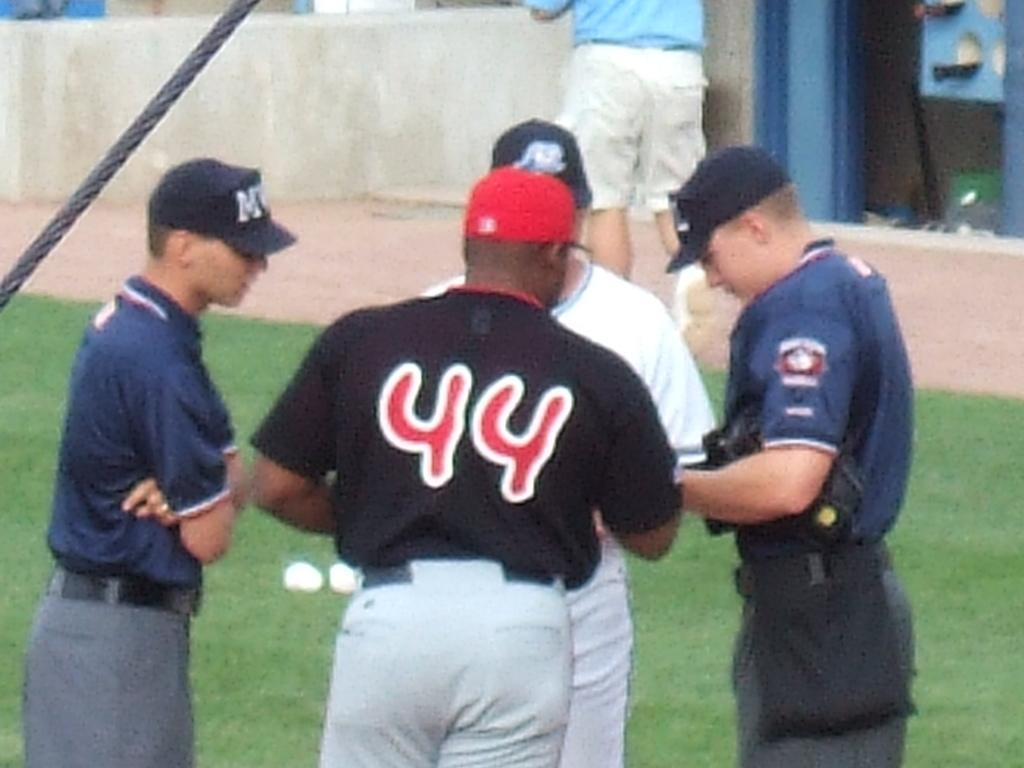Provide a one-sentence caption for the provided image. Men are in a huddle and the man with the red cap has a shirt reading 44. 